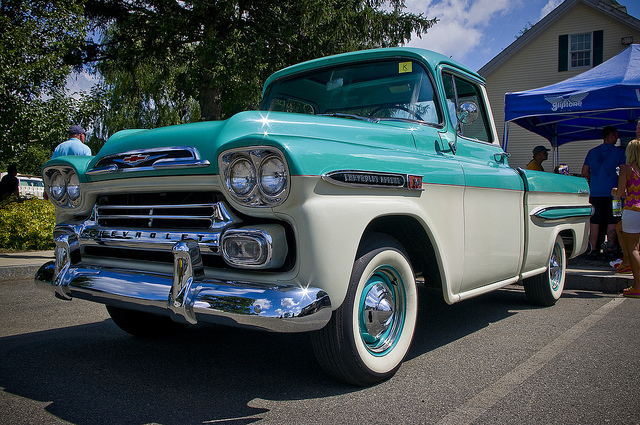Read and extract the text from this image. CHEVROLET 